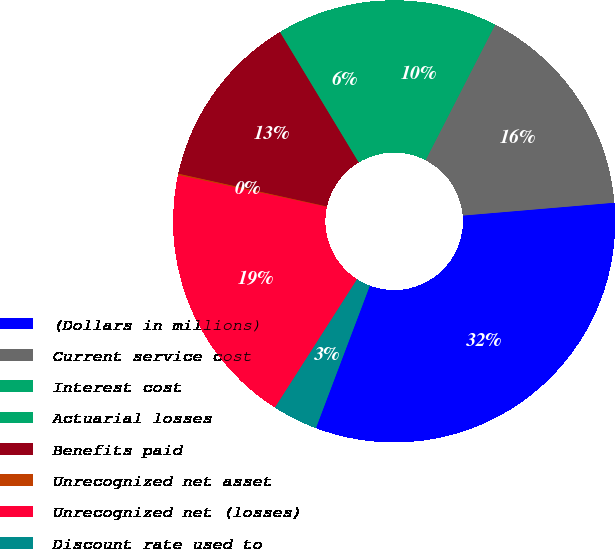<chart> <loc_0><loc_0><loc_500><loc_500><pie_chart><fcel>(Dollars in millions)<fcel>Current service cost<fcel>Interest cost<fcel>Actuarial losses<fcel>Benefits paid<fcel>Unrecognized net asset<fcel>Unrecognized net (losses)<fcel>Discount rate used to<nl><fcel>32.11%<fcel>16.1%<fcel>9.7%<fcel>6.5%<fcel>12.9%<fcel>0.1%<fcel>19.3%<fcel>3.3%<nl></chart> 